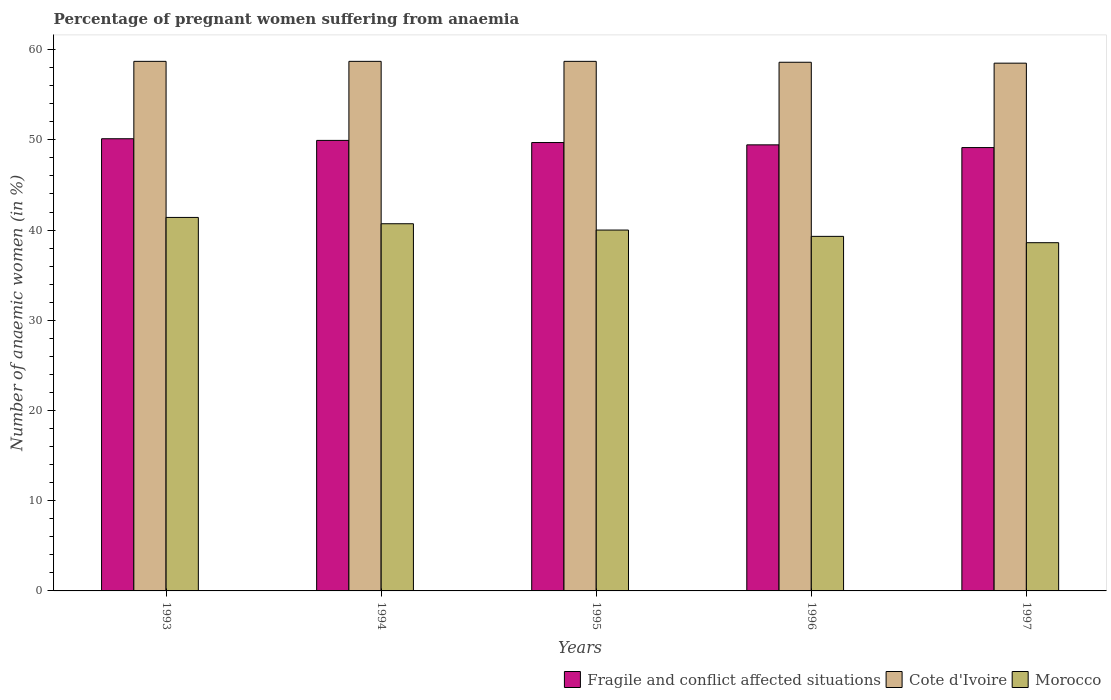Are the number of bars per tick equal to the number of legend labels?
Provide a succinct answer. Yes. Are the number of bars on each tick of the X-axis equal?
Your answer should be very brief. Yes. How many bars are there on the 3rd tick from the left?
Your response must be concise. 3. How many bars are there on the 3rd tick from the right?
Give a very brief answer. 3. What is the label of the 2nd group of bars from the left?
Keep it short and to the point. 1994. In how many cases, is the number of bars for a given year not equal to the number of legend labels?
Your response must be concise. 0. What is the number of anaemic women in Fragile and conflict affected situations in 1993?
Your answer should be compact. 50.12. Across all years, what is the maximum number of anaemic women in Cote d'Ivoire?
Your answer should be very brief. 58.7. Across all years, what is the minimum number of anaemic women in Fragile and conflict affected situations?
Your answer should be compact. 49.14. In which year was the number of anaemic women in Cote d'Ivoire minimum?
Your response must be concise. 1997. What is the total number of anaemic women in Morocco in the graph?
Provide a succinct answer. 200. What is the difference between the number of anaemic women in Cote d'Ivoire in 1995 and that in 1996?
Provide a short and direct response. 0.1. What is the difference between the number of anaemic women in Fragile and conflict affected situations in 1993 and the number of anaemic women in Morocco in 1996?
Your answer should be compact. 10.82. What is the average number of anaemic women in Morocco per year?
Your answer should be very brief. 40. In the year 1996, what is the difference between the number of anaemic women in Morocco and number of anaemic women in Cote d'Ivoire?
Provide a short and direct response. -19.3. What is the ratio of the number of anaemic women in Morocco in 1994 to that in 1997?
Offer a very short reply. 1.05. Is the number of anaemic women in Cote d'Ivoire in 1994 less than that in 1996?
Offer a very short reply. No. Is the difference between the number of anaemic women in Morocco in 1995 and 1997 greater than the difference between the number of anaemic women in Cote d'Ivoire in 1995 and 1997?
Give a very brief answer. Yes. What is the difference between the highest and the lowest number of anaemic women in Fragile and conflict affected situations?
Provide a short and direct response. 0.98. In how many years, is the number of anaemic women in Cote d'Ivoire greater than the average number of anaemic women in Cote d'Ivoire taken over all years?
Keep it short and to the point. 3. What does the 2nd bar from the left in 1993 represents?
Provide a short and direct response. Cote d'Ivoire. What does the 3rd bar from the right in 1997 represents?
Keep it short and to the point. Fragile and conflict affected situations. Is it the case that in every year, the sum of the number of anaemic women in Morocco and number of anaemic women in Fragile and conflict affected situations is greater than the number of anaemic women in Cote d'Ivoire?
Provide a succinct answer. Yes. How many bars are there?
Keep it short and to the point. 15. Are all the bars in the graph horizontal?
Offer a terse response. No. What is the difference between two consecutive major ticks on the Y-axis?
Make the answer very short. 10. Does the graph contain any zero values?
Ensure brevity in your answer.  No. Does the graph contain grids?
Provide a succinct answer. No. How are the legend labels stacked?
Your answer should be compact. Horizontal. What is the title of the graph?
Ensure brevity in your answer.  Percentage of pregnant women suffering from anaemia. Does "Lithuania" appear as one of the legend labels in the graph?
Offer a terse response. No. What is the label or title of the Y-axis?
Offer a very short reply. Number of anaemic women (in %). What is the Number of anaemic women (in %) in Fragile and conflict affected situations in 1993?
Make the answer very short. 50.12. What is the Number of anaemic women (in %) of Cote d'Ivoire in 1993?
Ensure brevity in your answer.  58.7. What is the Number of anaemic women (in %) in Morocco in 1993?
Keep it short and to the point. 41.4. What is the Number of anaemic women (in %) in Fragile and conflict affected situations in 1994?
Offer a terse response. 49.94. What is the Number of anaemic women (in %) of Cote d'Ivoire in 1994?
Give a very brief answer. 58.7. What is the Number of anaemic women (in %) in Morocco in 1994?
Your answer should be compact. 40.7. What is the Number of anaemic women (in %) in Fragile and conflict affected situations in 1995?
Provide a short and direct response. 49.7. What is the Number of anaemic women (in %) of Cote d'Ivoire in 1995?
Provide a succinct answer. 58.7. What is the Number of anaemic women (in %) of Morocco in 1995?
Provide a short and direct response. 40. What is the Number of anaemic women (in %) of Fragile and conflict affected situations in 1996?
Your response must be concise. 49.44. What is the Number of anaemic women (in %) in Cote d'Ivoire in 1996?
Give a very brief answer. 58.6. What is the Number of anaemic women (in %) of Morocco in 1996?
Make the answer very short. 39.3. What is the Number of anaemic women (in %) of Fragile and conflict affected situations in 1997?
Provide a short and direct response. 49.14. What is the Number of anaemic women (in %) in Cote d'Ivoire in 1997?
Offer a terse response. 58.5. What is the Number of anaemic women (in %) of Morocco in 1997?
Make the answer very short. 38.6. Across all years, what is the maximum Number of anaemic women (in %) in Fragile and conflict affected situations?
Offer a terse response. 50.12. Across all years, what is the maximum Number of anaemic women (in %) of Cote d'Ivoire?
Offer a terse response. 58.7. Across all years, what is the maximum Number of anaemic women (in %) of Morocco?
Keep it short and to the point. 41.4. Across all years, what is the minimum Number of anaemic women (in %) of Fragile and conflict affected situations?
Keep it short and to the point. 49.14. Across all years, what is the minimum Number of anaemic women (in %) of Cote d'Ivoire?
Offer a very short reply. 58.5. Across all years, what is the minimum Number of anaemic women (in %) of Morocco?
Provide a short and direct response. 38.6. What is the total Number of anaemic women (in %) in Fragile and conflict affected situations in the graph?
Make the answer very short. 248.35. What is the total Number of anaemic women (in %) in Cote d'Ivoire in the graph?
Ensure brevity in your answer.  293.2. What is the difference between the Number of anaemic women (in %) of Fragile and conflict affected situations in 1993 and that in 1994?
Your answer should be compact. 0.18. What is the difference between the Number of anaemic women (in %) in Cote d'Ivoire in 1993 and that in 1994?
Your answer should be very brief. 0. What is the difference between the Number of anaemic women (in %) in Fragile and conflict affected situations in 1993 and that in 1995?
Ensure brevity in your answer.  0.42. What is the difference between the Number of anaemic women (in %) in Fragile and conflict affected situations in 1993 and that in 1996?
Provide a short and direct response. 0.68. What is the difference between the Number of anaemic women (in %) of Fragile and conflict affected situations in 1993 and that in 1997?
Ensure brevity in your answer.  0.98. What is the difference between the Number of anaemic women (in %) in Fragile and conflict affected situations in 1994 and that in 1995?
Ensure brevity in your answer.  0.24. What is the difference between the Number of anaemic women (in %) in Morocco in 1994 and that in 1995?
Your answer should be very brief. 0.7. What is the difference between the Number of anaemic women (in %) in Fragile and conflict affected situations in 1994 and that in 1996?
Keep it short and to the point. 0.49. What is the difference between the Number of anaemic women (in %) in Fragile and conflict affected situations in 1994 and that in 1997?
Your response must be concise. 0.8. What is the difference between the Number of anaemic women (in %) of Morocco in 1994 and that in 1997?
Your answer should be compact. 2.1. What is the difference between the Number of anaemic women (in %) in Fragile and conflict affected situations in 1995 and that in 1996?
Make the answer very short. 0.26. What is the difference between the Number of anaemic women (in %) of Cote d'Ivoire in 1995 and that in 1996?
Offer a terse response. 0.1. What is the difference between the Number of anaemic women (in %) of Morocco in 1995 and that in 1996?
Keep it short and to the point. 0.7. What is the difference between the Number of anaemic women (in %) in Fragile and conflict affected situations in 1995 and that in 1997?
Your response must be concise. 0.56. What is the difference between the Number of anaemic women (in %) in Cote d'Ivoire in 1995 and that in 1997?
Offer a very short reply. 0.2. What is the difference between the Number of anaemic women (in %) of Fragile and conflict affected situations in 1996 and that in 1997?
Give a very brief answer. 0.3. What is the difference between the Number of anaemic women (in %) in Cote d'Ivoire in 1996 and that in 1997?
Offer a terse response. 0.1. What is the difference between the Number of anaemic women (in %) in Fragile and conflict affected situations in 1993 and the Number of anaemic women (in %) in Cote d'Ivoire in 1994?
Make the answer very short. -8.58. What is the difference between the Number of anaemic women (in %) of Fragile and conflict affected situations in 1993 and the Number of anaemic women (in %) of Morocco in 1994?
Give a very brief answer. 9.42. What is the difference between the Number of anaemic women (in %) in Cote d'Ivoire in 1993 and the Number of anaemic women (in %) in Morocco in 1994?
Provide a short and direct response. 18. What is the difference between the Number of anaemic women (in %) of Fragile and conflict affected situations in 1993 and the Number of anaemic women (in %) of Cote d'Ivoire in 1995?
Your answer should be compact. -8.58. What is the difference between the Number of anaemic women (in %) of Fragile and conflict affected situations in 1993 and the Number of anaemic women (in %) of Morocco in 1995?
Offer a terse response. 10.12. What is the difference between the Number of anaemic women (in %) of Fragile and conflict affected situations in 1993 and the Number of anaemic women (in %) of Cote d'Ivoire in 1996?
Your answer should be compact. -8.48. What is the difference between the Number of anaemic women (in %) in Fragile and conflict affected situations in 1993 and the Number of anaemic women (in %) in Morocco in 1996?
Make the answer very short. 10.82. What is the difference between the Number of anaemic women (in %) in Cote d'Ivoire in 1993 and the Number of anaemic women (in %) in Morocco in 1996?
Provide a short and direct response. 19.4. What is the difference between the Number of anaemic women (in %) of Fragile and conflict affected situations in 1993 and the Number of anaemic women (in %) of Cote d'Ivoire in 1997?
Give a very brief answer. -8.38. What is the difference between the Number of anaemic women (in %) in Fragile and conflict affected situations in 1993 and the Number of anaemic women (in %) in Morocco in 1997?
Your answer should be compact. 11.52. What is the difference between the Number of anaemic women (in %) in Cote d'Ivoire in 1993 and the Number of anaemic women (in %) in Morocco in 1997?
Your answer should be compact. 20.1. What is the difference between the Number of anaemic women (in %) of Fragile and conflict affected situations in 1994 and the Number of anaemic women (in %) of Cote d'Ivoire in 1995?
Make the answer very short. -8.76. What is the difference between the Number of anaemic women (in %) in Fragile and conflict affected situations in 1994 and the Number of anaemic women (in %) in Morocco in 1995?
Provide a short and direct response. 9.94. What is the difference between the Number of anaemic women (in %) in Cote d'Ivoire in 1994 and the Number of anaemic women (in %) in Morocco in 1995?
Provide a short and direct response. 18.7. What is the difference between the Number of anaemic women (in %) in Fragile and conflict affected situations in 1994 and the Number of anaemic women (in %) in Cote d'Ivoire in 1996?
Make the answer very short. -8.66. What is the difference between the Number of anaemic women (in %) of Fragile and conflict affected situations in 1994 and the Number of anaemic women (in %) of Morocco in 1996?
Give a very brief answer. 10.64. What is the difference between the Number of anaemic women (in %) of Cote d'Ivoire in 1994 and the Number of anaemic women (in %) of Morocco in 1996?
Ensure brevity in your answer.  19.4. What is the difference between the Number of anaemic women (in %) of Fragile and conflict affected situations in 1994 and the Number of anaemic women (in %) of Cote d'Ivoire in 1997?
Keep it short and to the point. -8.56. What is the difference between the Number of anaemic women (in %) in Fragile and conflict affected situations in 1994 and the Number of anaemic women (in %) in Morocco in 1997?
Give a very brief answer. 11.34. What is the difference between the Number of anaemic women (in %) in Cote d'Ivoire in 1994 and the Number of anaemic women (in %) in Morocco in 1997?
Offer a very short reply. 20.1. What is the difference between the Number of anaemic women (in %) in Fragile and conflict affected situations in 1995 and the Number of anaemic women (in %) in Cote d'Ivoire in 1996?
Ensure brevity in your answer.  -8.9. What is the difference between the Number of anaemic women (in %) in Fragile and conflict affected situations in 1995 and the Number of anaemic women (in %) in Morocco in 1996?
Offer a terse response. 10.4. What is the difference between the Number of anaemic women (in %) in Fragile and conflict affected situations in 1995 and the Number of anaemic women (in %) in Cote d'Ivoire in 1997?
Your answer should be very brief. -8.8. What is the difference between the Number of anaemic women (in %) in Fragile and conflict affected situations in 1995 and the Number of anaemic women (in %) in Morocco in 1997?
Your answer should be compact. 11.1. What is the difference between the Number of anaemic women (in %) in Cote d'Ivoire in 1995 and the Number of anaemic women (in %) in Morocco in 1997?
Keep it short and to the point. 20.1. What is the difference between the Number of anaemic women (in %) of Fragile and conflict affected situations in 1996 and the Number of anaemic women (in %) of Cote d'Ivoire in 1997?
Offer a terse response. -9.06. What is the difference between the Number of anaemic women (in %) of Fragile and conflict affected situations in 1996 and the Number of anaemic women (in %) of Morocco in 1997?
Keep it short and to the point. 10.84. What is the average Number of anaemic women (in %) of Fragile and conflict affected situations per year?
Offer a terse response. 49.67. What is the average Number of anaemic women (in %) of Cote d'Ivoire per year?
Offer a terse response. 58.64. What is the average Number of anaemic women (in %) of Morocco per year?
Provide a succinct answer. 40. In the year 1993, what is the difference between the Number of anaemic women (in %) in Fragile and conflict affected situations and Number of anaemic women (in %) in Cote d'Ivoire?
Your answer should be compact. -8.58. In the year 1993, what is the difference between the Number of anaemic women (in %) of Fragile and conflict affected situations and Number of anaemic women (in %) of Morocco?
Ensure brevity in your answer.  8.72. In the year 1993, what is the difference between the Number of anaemic women (in %) of Cote d'Ivoire and Number of anaemic women (in %) of Morocco?
Provide a short and direct response. 17.3. In the year 1994, what is the difference between the Number of anaemic women (in %) of Fragile and conflict affected situations and Number of anaemic women (in %) of Cote d'Ivoire?
Offer a very short reply. -8.76. In the year 1994, what is the difference between the Number of anaemic women (in %) in Fragile and conflict affected situations and Number of anaemic women (in %) in Morocco?
Ensure brevity in your answer.  9.24. In the year 1994, what is the difference between the Number of anaemic women (in %) in Cote d'Ivoire and Number of anaemic women (in %) in Morocco?
Provide a short and direct response. 18. In the year 1995, what is the difference between the Number of anaemic women (in %) in Fragile and conflict affected situations and Number of anaemic women (in %) in Cote d'Ivoire?
Offer a terse response. -9. In the year 1995, what is the difference between the Number of anaemic women (in %) in Fragile and conflict affected situations and Number of anaemic women (in %) in Morocco?
Give a very brief answer. 9.7. In the year 1995, what is the difference between the Number of anaemic women (in %) in Cote d'Ivoire and Number of anaemic women (in %) in Morocco?
Provide a short and direct response. 18.7. In the year 1996, what is the difference between the Number of anaemic women (in %) of Fragile and conflict affected situations and Number of anaemic women (in %) of Cote d'Ivoire?
Make the answer very short. -9.16. In the year 1996, what is the difference between the Number of anaemic women (in %) in Fragile and conflict affected situations and Number of anaemic women (in %) in Morocco?
Your response must be concise. 10.14. In the year 1996, what is the difference between the Number of anaemic women (in %) in Cote d'Ivoire and Number of anaemic women (in %) in Morocco?
Ensure brevity in your answer.  19.3. In the year 1997, what is the difference between the Number of anaemic women (in %) of Fragile and conflict affected situations and Number of anaemic women (in %) of Cote d'Ivoire?
Offer a terse response. -9.36. In the year 1997, what is the difference between the Number of anaemic women (in %) in Fragile and conflict affected situations and Number of anaemic women (in %) in Morocco?
Offer a very short reply. 10.54. In the year 1997, what is the difference between the Number of anaemic women (in %) of Cote d'Ivoire and Number of anaemic women (in %) of Morocco?
Provide a short and direct response. 19.9. What is the ratio of the Number of anaemic women (in %) in Fragile and conflict affected situations in 1993 to that in 1994?
Your response must be concise. 1. What is the ratio of the Number of anaemic women (in %) of Cote d'Ivoire in 1993 to that in 1994?
Provide a short and direct response. 1. What is the ratio of the Number of anaemic women (in %) in Morocco in 1993 to that in 1994?
Offer a terse response. 1.02. What is the ratio of the Number of anaemic women (in %) of Fragile and conflict affected situations in 1993 to that in 1995?
Keep it short and to the point. 1.01. What is the ratio of the Number of anaemic women (in %) of Cote d'Ivoire in 1993 to that in 1995?
Keep it short and to the point. 1. What is the ratio of the Number of anaemic women (in %) in Morocco in 1993 to that in 1995?
Your response must be concise. 1.03. What is the ratio of the Number of anaemic women (in %) in Fragile and conflict affected situations in 1993 to that in 1996?
Your answer should be very brief. 1.01. What is the ratio of the Number of anaemic women (in %) in Morocco in 1993 to that in 1996?
Provide a short and direct response. 1.05. What is the ratio of the Number of anaemic women (in %) in Fragile and conflict affected situations in 1993 to that in 1997?
Your answer should be compact. 1.02. What is the ratio of the Number of anaemic women (in %) in Morocco in 1993 to that in 1997?
Keep it short and to the point. 1.07. What is the ratio of the Number of anaemic women (in %) in Cote d'Ivoire in 1994 to that in 1995?
Keep it short and to the point. 1. What is the ratio of the Number of anaemic women (in %) in Morocco in 1994 to that in 1995?
Your answer should be very brief. 1.02. What is the ratio of the Number of anaemic women (in %) in Cote d'Ivoire in 1994 to that in 1996?
Provide a short and direct response. 1. What is the ratio of the Number of anaemic women (in %) of Morocco in 1994 to that in 1996?
Your answer should be compact. 1.04. What is the ratio of the Number of anaemic women (in %) in Fragile and conflict affected situations in 1994 to that in 1997?
Your answer should be compact. 1.02. What is the ratio of the Number of anaemic women (in %) of Cote d'Ivoire in 1994 to that in 1997?
Your response must be concise. 1. What is the ratio of the Number of anaemic women (in %) in Morocco in 1994 to that in 1997?
Your response must be concise. 1.05. What is the ratio of the Number of anaemic women (in %) of Fragile and conflict affected situations in 1995 to that in 1996?
Make the answer very short. 1.01. What is the ratio of the Number of anaemic women (in %) of Cote d'Ivoire in 1995 to that in 1996?
Your response must be concise. 1. What is the ratio of the Number of anaemic women (in %) of Morocco in 1995 to that in 1996?
Your answer should be very brief. 1.02. What is the ratio of the Number of anaemic women (in %) of Fragile and conflict affected situations in 1995 to that in 1997?
Your answer should be compact. 1.01. What is the ratio of the Number of anaemic women (in %) of Morocco in 1995 to that in 1997?
Provide a succinct answer. 1.04. What is the ratio of the Number of anaemic women (in %) in Fragile and conflict affected situations in 1996 to that in 1997?
Offer a very short reply. 1.01. What is the ratio of the Number of anaemic women (in %) of Cote d'Ivoire in 1996 to that in 1997?
Give a very brief answer. 1. What is the ratio of the Number of anaemic women (in %) of Morocco in 1996 to that in 1997?
Provide a short and direct response. 1.02. What is the difference between the highest and the second highest Number of anaemic women (in %) in Fragile and conflict affected situations?
Ensure brevity in your answer.  0.18. What is the difference between the highest and the second highest Number of anaemic women (in %) in Cote d'Ivoire?
Ensure brevity in your answer.  0. What is the difference between the highest and the second highest Number of anaemic women (in %) in Morocco?
Give a very brief answer. 0.7. What is the difference between the highest and the lowest Number of anaemic women (in %) of Fragile and conflict affected situations?
Provide a succinct answer. 0.98. What is the difference between the highest and the lowest Number of anaemic women (in %) in Cote d'Ivoire?
Your answer should be very brief. 0.2. 